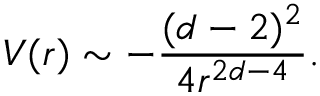Convert formula to latex. <formula><loc_0><loc_0><loc_500><loc_500>V ( r ) \sim - \frac { ( d - 2 ) ^ { 2 } } { 4 r ^ { 2 d - 4 } } .</formula> 